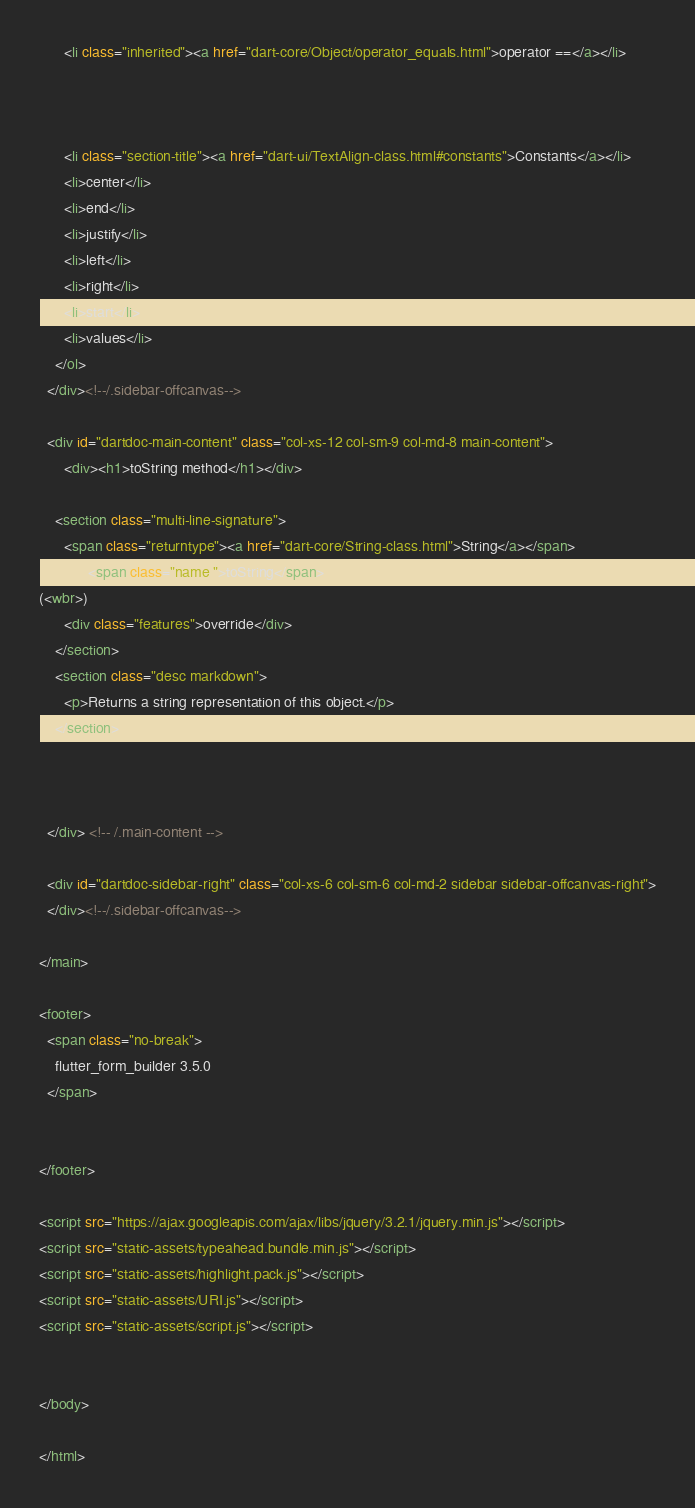<code> <loc_0><loc_0><loc_500><loc_500><_HTML_>      <li class="inherited"><a href="dart-core/Object/operator_equals.html">operator ==</a></li>
    
    
    
      <li class="section-title"><a href="dart-ui/TextAlign-class.html#constants">Constants</a></li>
      <li>center</li>
      <li>end</li>
      <li>justify</li>
      <li>left</li>
      <li>right</li>
      <li>start</li>
      <li>values</li>
    </ol>
  </div><!--/.sidebar-offcanvas-->

  <div id="dartdoc-main-content" class="col-xs-12 col-sm-9 col-md-8 main-content">
      <div><h1>toString method</h1></div>

    <section class="multi-line-signature">
      <span class="returntype"><a href="dart-core/String-class.html">String</a></span>
            <span class="name ">toString</span>
(<wbr>)
      <div class="features">override</div>
    </section>
    <section class="desc markdown">
      <p>Returns a string representation of this object.</p>
    </section>
    
    

  </div> <!-- /.main-content -->

  <div id="dartdoc-sidebar-right" class="col-xs-6 col-sm-6 col-md-2 sidebar sidebar-offcanvas-right">
  </div><!--/.sidebar-offcanvas-->

</main>

<footer>
  <span class="no-break">
    flutter_form_builder 3.5.0
  </span>

  
</footer>

<script src="https://ajax.googleapis.com/ajax/libs/jquery/3.2.1/jquery.min.js"></script>
<script src="static-assets/typeahead.bundle.min.js"></script>
<script src="static-assets/highlight.pack.js"></script>
<script src="static-assets/URI.js"></script>
<script src="static-assets/script.js"></script>


</body>

</html>
</code> 